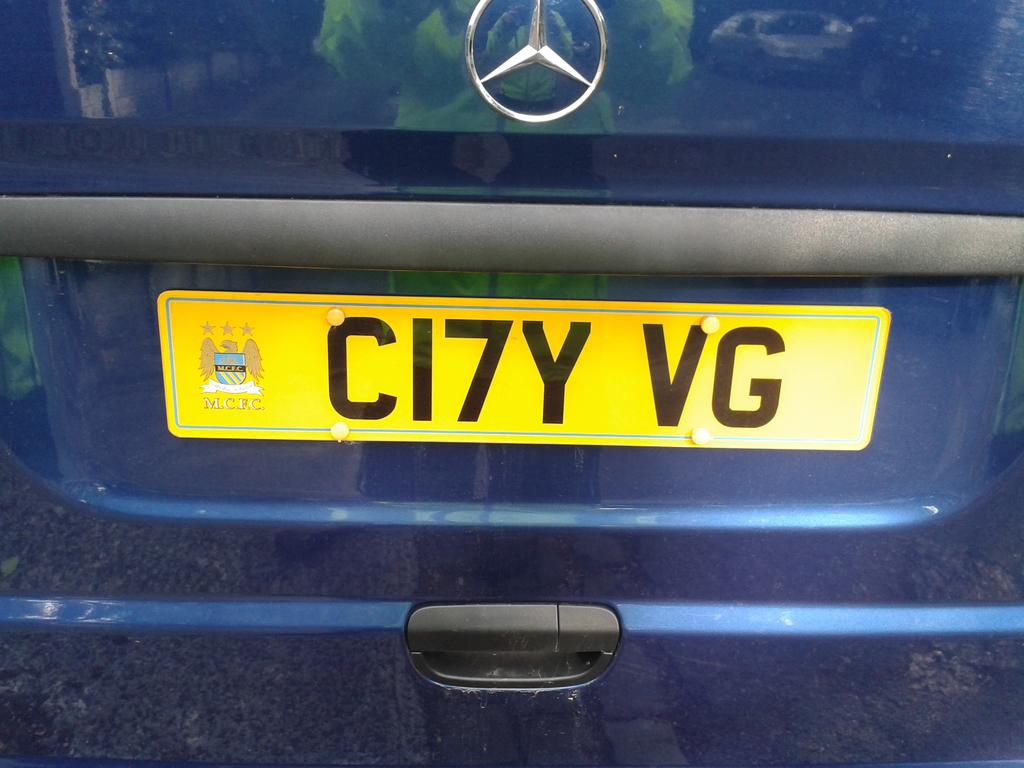What is the car's license plate number?
Make the answer very short. Ci7y vg. What are the letters written under the emblem on the left?
Your response must be concise. Mcfc. 